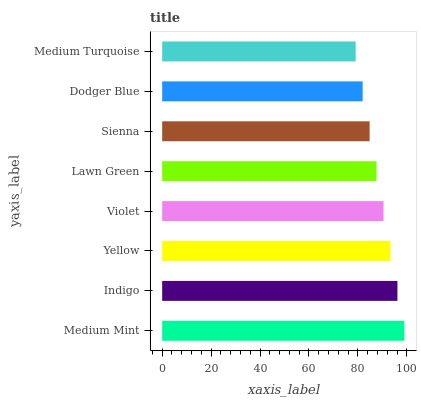Is Medium Turquoise the minimum?
Answer yes or no. Yes. Is Medium Mint the maximum?
Answer yes or no. Yes. Is Indigo the minimum?
Answer yes or no. No. Is Indigo the maximum?
Answer yes or no. No. Is Medium Mint greater than Indigo?
Answer yes or no. Yes. Is Indigo less than Medium Mint?
Answer yes or no. Yes. Is Indigo greater than Medium Mint?
Answer yes or no. No. Is Medium Mint less than Indigo?
Answer yes or no. No. Is Violet the high median?
Answer yes or no. Yes. Is Lawn Green the low median?
Answer yes or no. Yes. Is Lawn Green the high median?
Answer yes or no. No. Is Medium Mint the low median?
Answer yes or no. No. 